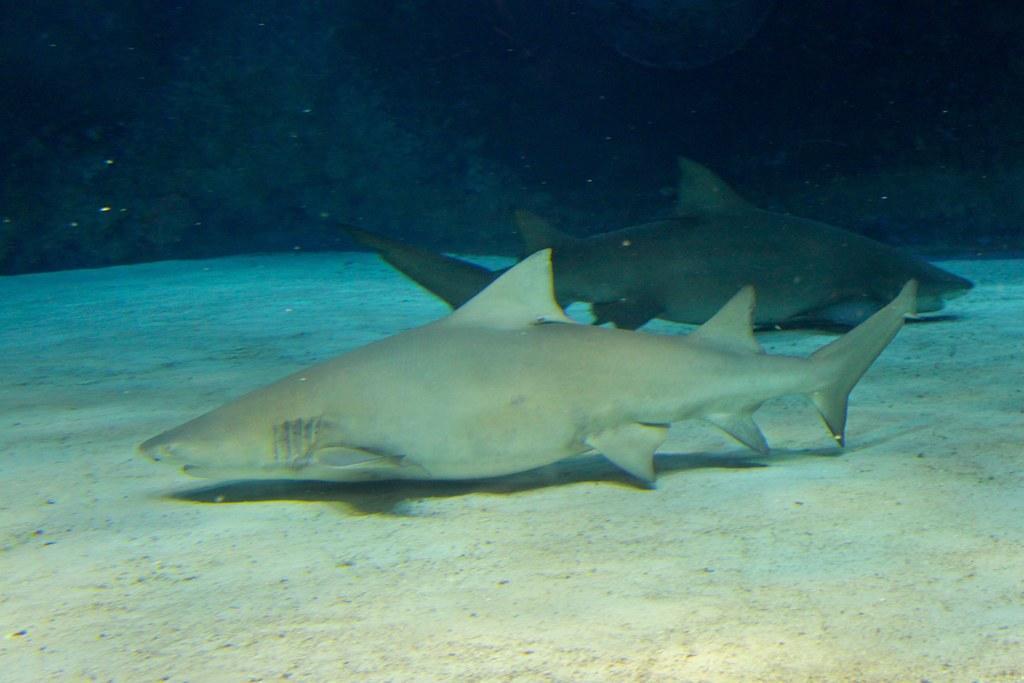Can you describe this image briefly? In the image we can see there are two fish of different colors. 